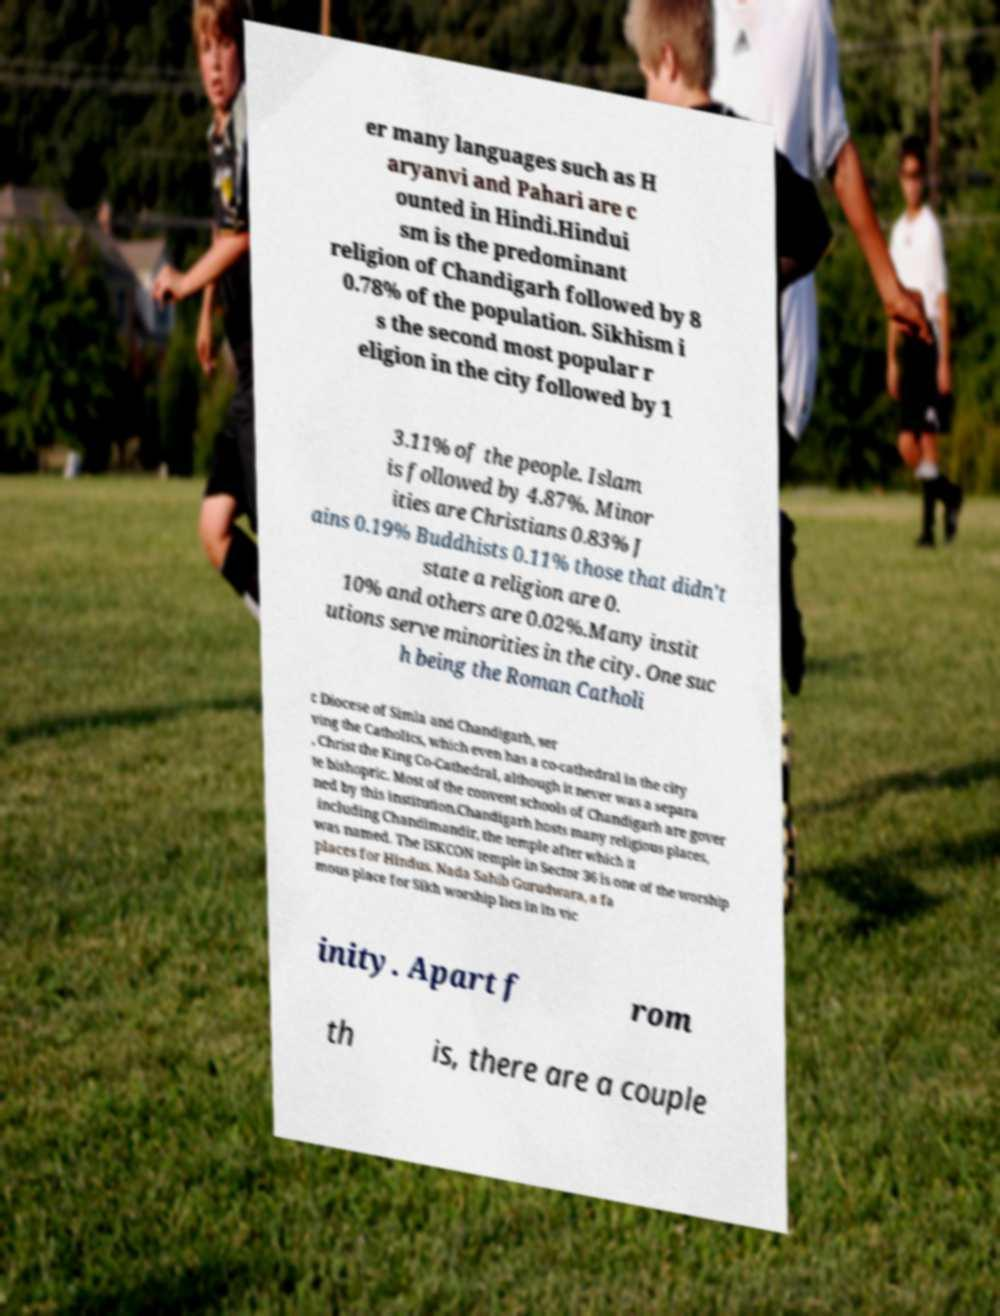There's text embedded in this image that I need extracted. Can you transcribe it verbatim? er many languages such as H aryanvi and Pahari are c ounted in Hindi.Hindui sm is the predominant religion of Chandigarh followed by 8 0.78% of the population. Sikhism i s the second most popular r eligion in the city followed by 1 3.11% of the people. Islam is followed by 4.87%. Minor ities are Christians 0.83% J ains 0.19% Buddhists 0.11% those that didn't state a religion are 0. 10% and others are 0.02%.Many instit utions serve minorities in the city. One suc h being the Roman Catholi c Diocese of Simla and Chandigarh, ser ving the Catholics, which even has a co-cathedral in the city , Christ the King Co-Cathedral, although it never was a separa te bishopric. Most of the convent schools of Chandigarh are gover ned by this institution.Chandigarh hosts many religious places, including Chandimandir, the temple after which it was named. The ISKCON temple in Sector 36 is one of the worship places for Hindus. Nada Sahib Gurudwara, a fa mous place for Sikh worship lies in its vic inity. Apart f rom th is, there are a couple 